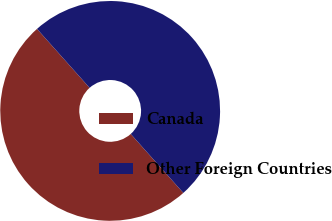<chart> <loc_0><loc_0><loc_500><loc_500><pie_chart><fcel>Canada<fcel>Other Foreign Countries<nl><fcel>50.0%<fcel>50.0%<nl></chart> 